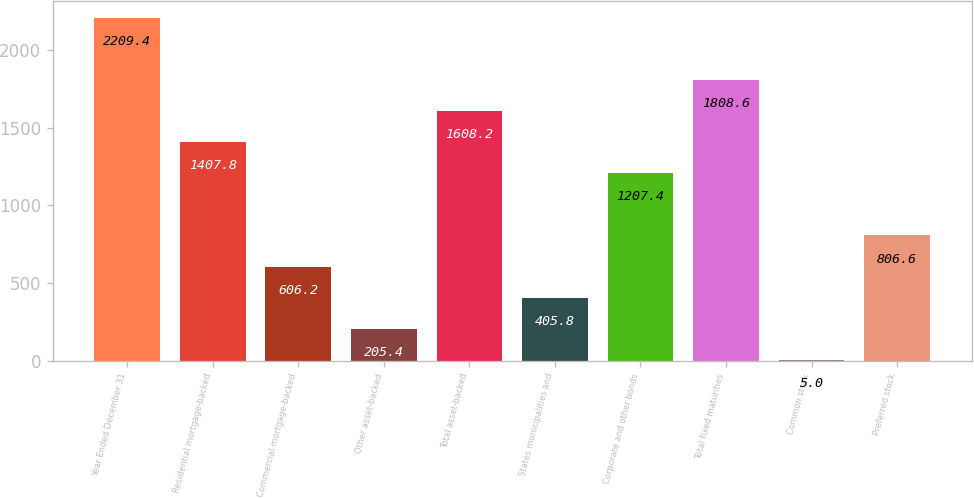<chart> <loc_0><loc_0><loc_500><loc_500><bar_chart><fcel>Year Ended December 31<fcel>Residential mortgage-backed<fcel>Commercial mortgage-backed<fcel>Other asset-backed<fcel>Total asset-backed<fcel>States municipalities and<fcel>Corporate and other bonds<fcel>Total fixed maturities<fcel>Common stock<fcel>Preferred stock<nl><fcel>2209.4<fcel>1407.8<fcel>606.2<fcel>205.4<fcel>1608.2<fcel>405.8<fcel>1207.4<fcel>1808.6<fcel>5<fcel>806.6<nl></chart> 